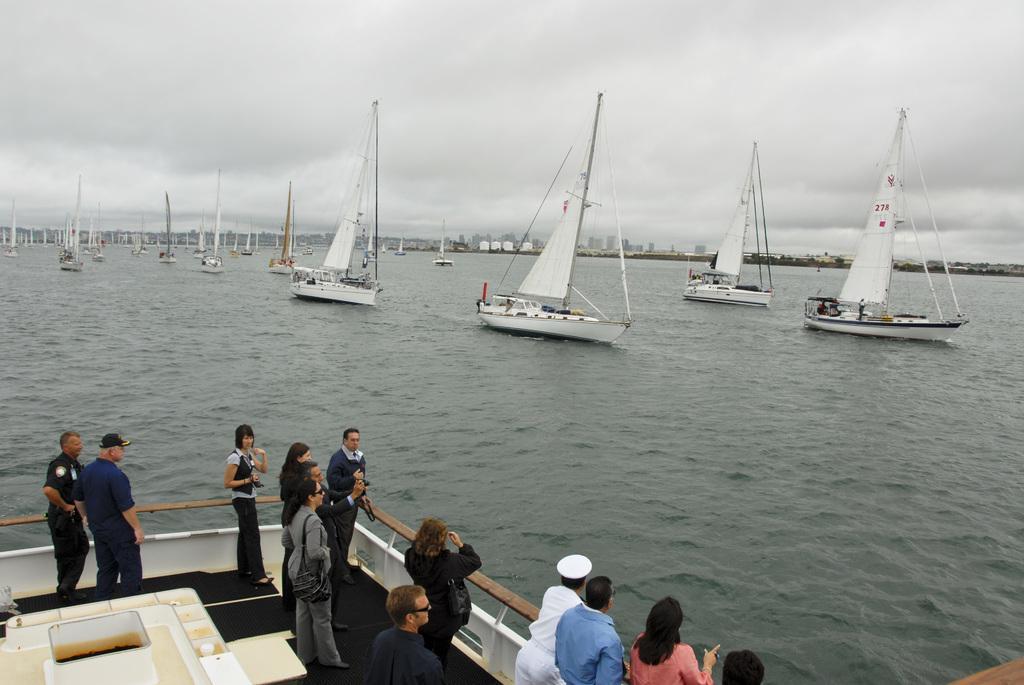Please provide a concise description of this image. In the bottom left corner of the image there is a boat, in the boat few people are standing and watching. In front of them there is water, above the water there are some boats. Behind the boats we can see some buildings and trees. At the top of the image there are some clouds in the sky. 